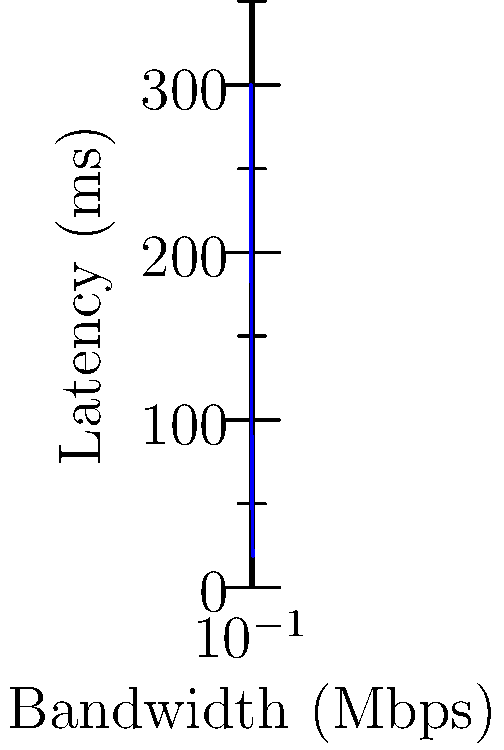Based on the graph showing the relationship between bandwidth and latency for online duet performances, which point represents the minimum recommended bandwidth for high-quality audio streaming with acceptable latency for real-time collaboration? To determine the minimum recommended bandwidth for high-quality audio streaming in online duet performances, we need to consider both audio quality and latency:

1. Audio quality: High-quality audio typically requires at least 256 Kbps (0.256 Mbps) for stereo transmission.

2. Latency: For real-time collaboration, latency should be below 100 ms to maintain synchronization between performers.

3. Analyzing the graph:
   - Point A (0.128 Mbps): Too low for high-quality audio, latency too high (300 ms)
   - Point B (0.256 Mbps): Minimum for high-quality audio, but latency still high (150 ms)
   - Point C (0.512 Mbps): Sufficient for high-quality audio, latency acceptable (75 ms)
   - Points D and E: Better quality and lower latency, but not the minimum required

4. Conclusion: Point C (0.512 Mbps) represents the minimum recommended bandwidth that satisfies both high-quality audio requirements and acceptable latency for real-time collaboration.
Answer: Point C (0.512 Mbps) 